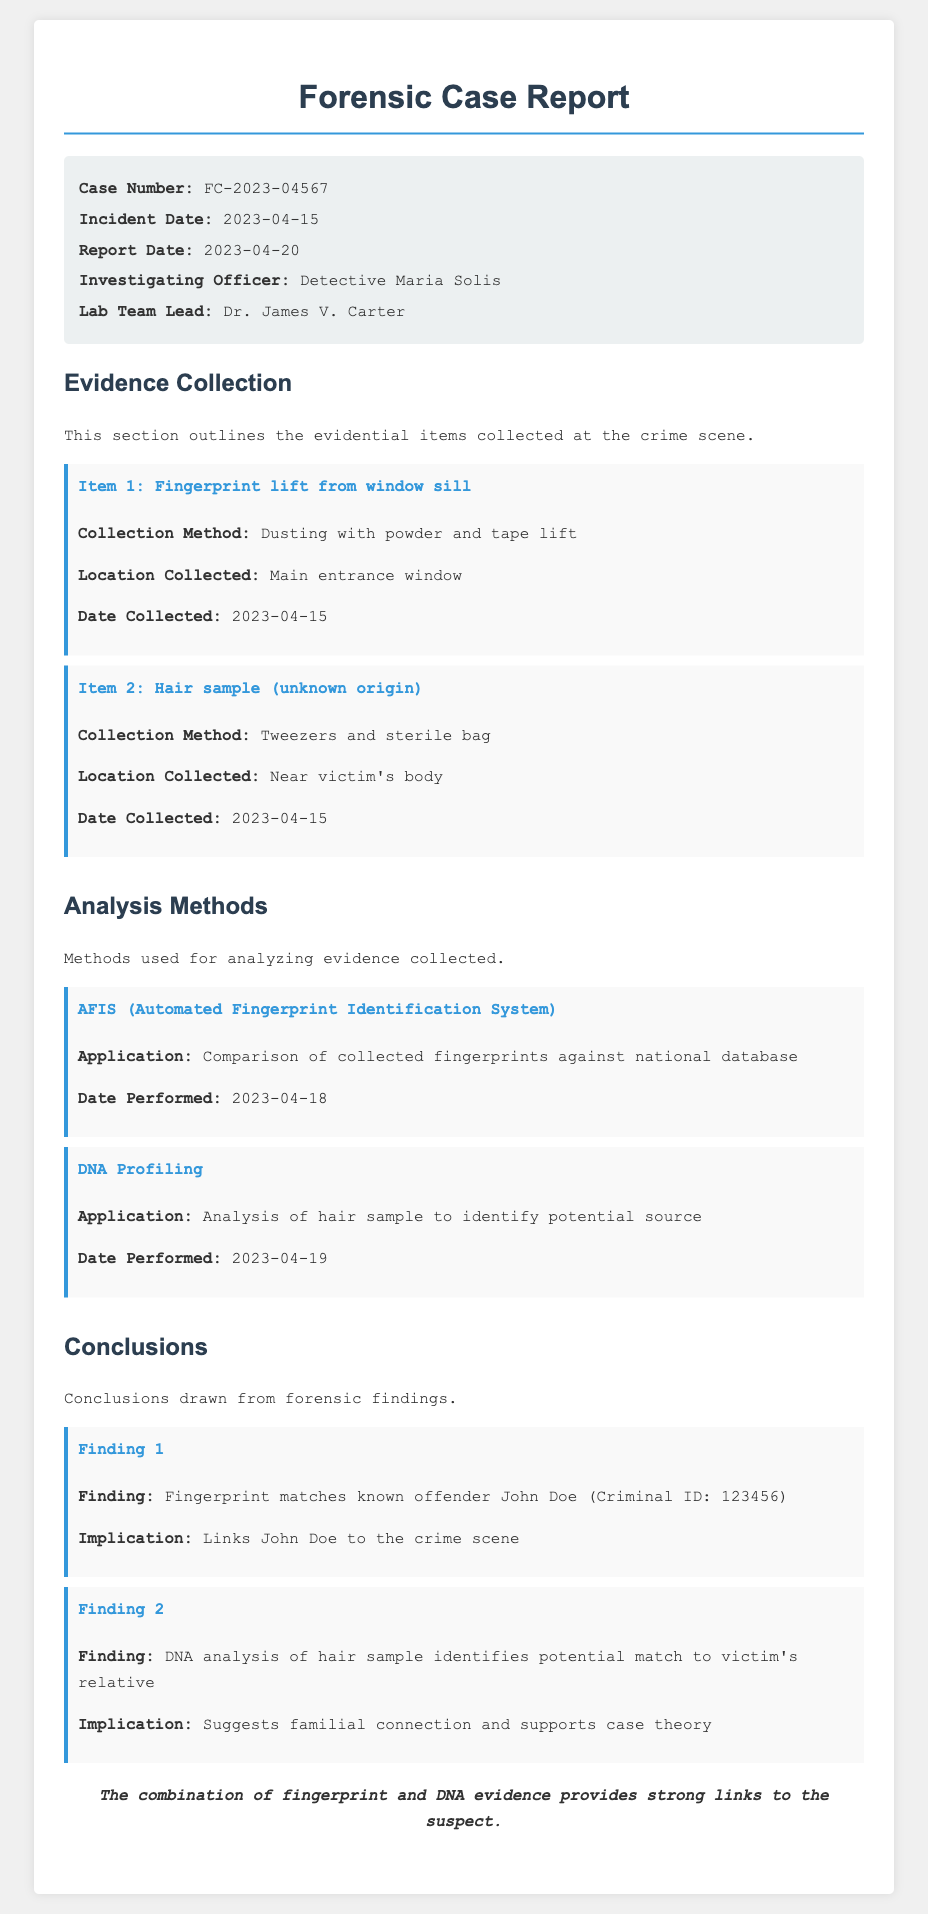What is the case number? The case number is listed in the case details section of the document, which is FC-2023-04567.
Answer: FC-2023-04567 Who is the Investigating Officer? The name of the investigating officer is presented in the case details section, which is Detective Maria Solis.
Answer: Detective Maria Solis What item was collected from the main entrance window? The evidence item collected from the main entrance window is specified as a fingerprint lift.
Answer: Fingerprint lift from window sill When was DNA profiling performed? The date DNA profiling was performed is found in the analysis methods section, which is 2023-04-19.
Answer: 2023-04-19 What matching result was found for fingerprint evidence? The finding regarding the fingerprint evidence states it matched known offender John Doe.
Answer: John Doe What method was used for hair sample analysis? The method used for analyzing the hair sample is identified in the analysis methods section as DNA profiling.
Answer: DNA Profiling How many pieces of evidence are listed? The document enumerates two pieces of evidence in the evidence collection section.
Answer: Two What does Finding 2 suggest? Finding 2 in the conclusions drawn suggests a familial connection to the victim.
Answer: Familial connection 